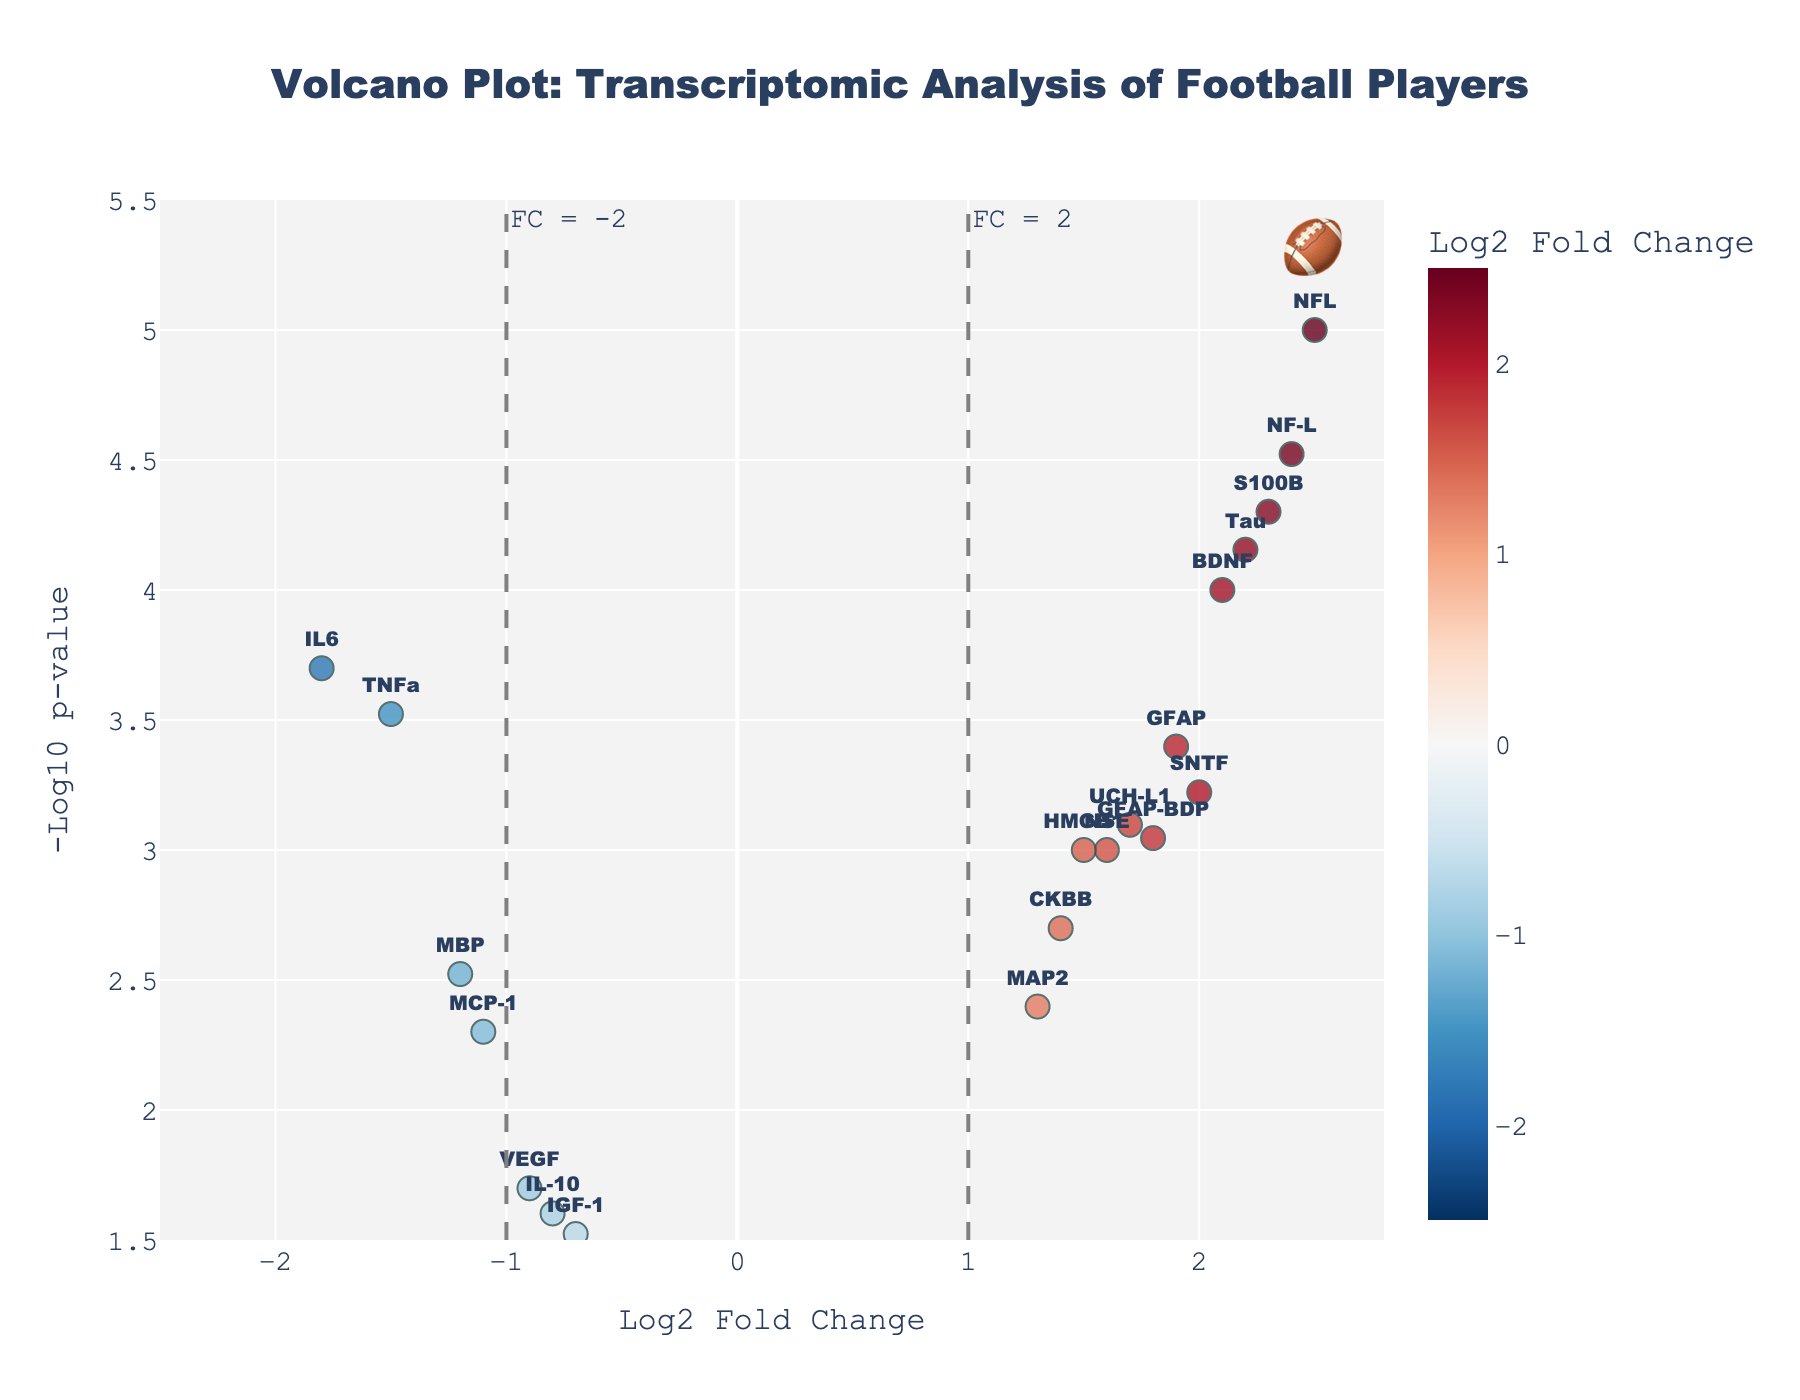How many genes are represented in the figure? Count the number of unique data points representing genes in the plot.
Answer: 20 What is the title of the figure? Look at the top center of the plot to read the title.
Answer: Volcano Plot: Transcriptomic Analysis of Football Players Which gene shows the highest log2 fold change? Identify the gene with the maximum value on the x-axis labeled as 'Log2 Fold Change'.
Answer: NFL Which gene has the lowest p-value? Determine the gene with the highest value on the y-axis labeled as '-Log10 p-value' as higher -Log10 p-value indicates a lower actual p-value.
Answer: NFL What is the log2 fold change and p-value of IL6? Refer to the data point labeled 'IL6' and read its coordinates on the x-axis and y-axis.
Answer: -1.8, 0.0002 Which genes are marked as having significant p-values (p < 0.05) based on the threshold line? Identify all genes whose y-values are above the horizontal dashed line indicating -Log10(0.05).
Answer: IL6, TNFa, BDNF, GFAP, S100B, NFL, UCH-L1, NSE, MBP, SNTF, GFAP-BDP, CKBB, MAP2, Tau, NF-L, HMGB1, MCP-1 How many genes show a negative log2 fold change? Count the data points that fall to the left side of the vertical axis where log2 fold change is negative.
Answer: 6 Which gene with a positive log2 fold change has the least significance? Identify the gene with a positive log2 fold change (right side of the plot) and lowest y-value.
Answer: IGF-1 By how much does the -log10(pValue) of NFL exceed that of GFAP? Calculate the difference between their y-values: -Log10(pValue)NFL - -Log10(pValue)GFAP.
Answer: 2.4 